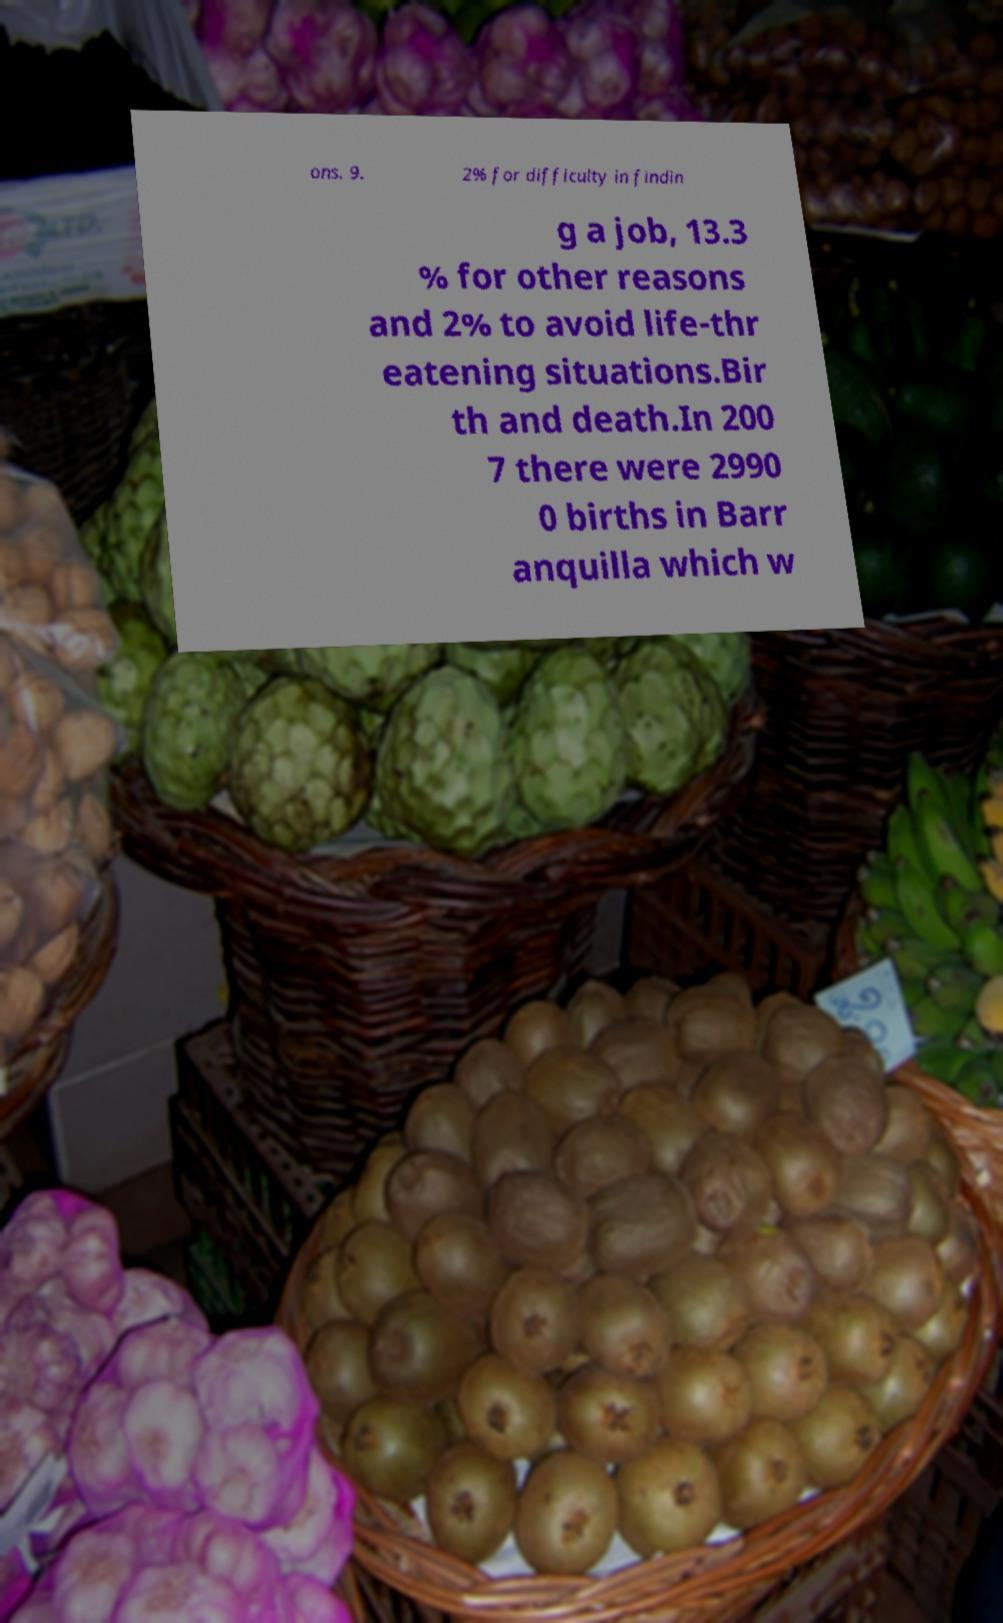Could you extract and type out the text from this image? ons. 9. 2% for difficulty in findin g a job, 13.3 % for other reasons and 2% to avoid life-thr eatening situations.Bir th and death.In 200 7 there were 2990 0 births in Barr anquilla which w 